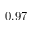<formula> <loc_0><loc_0><loc_500><loc_500>- 0 . 9 7</formula> 